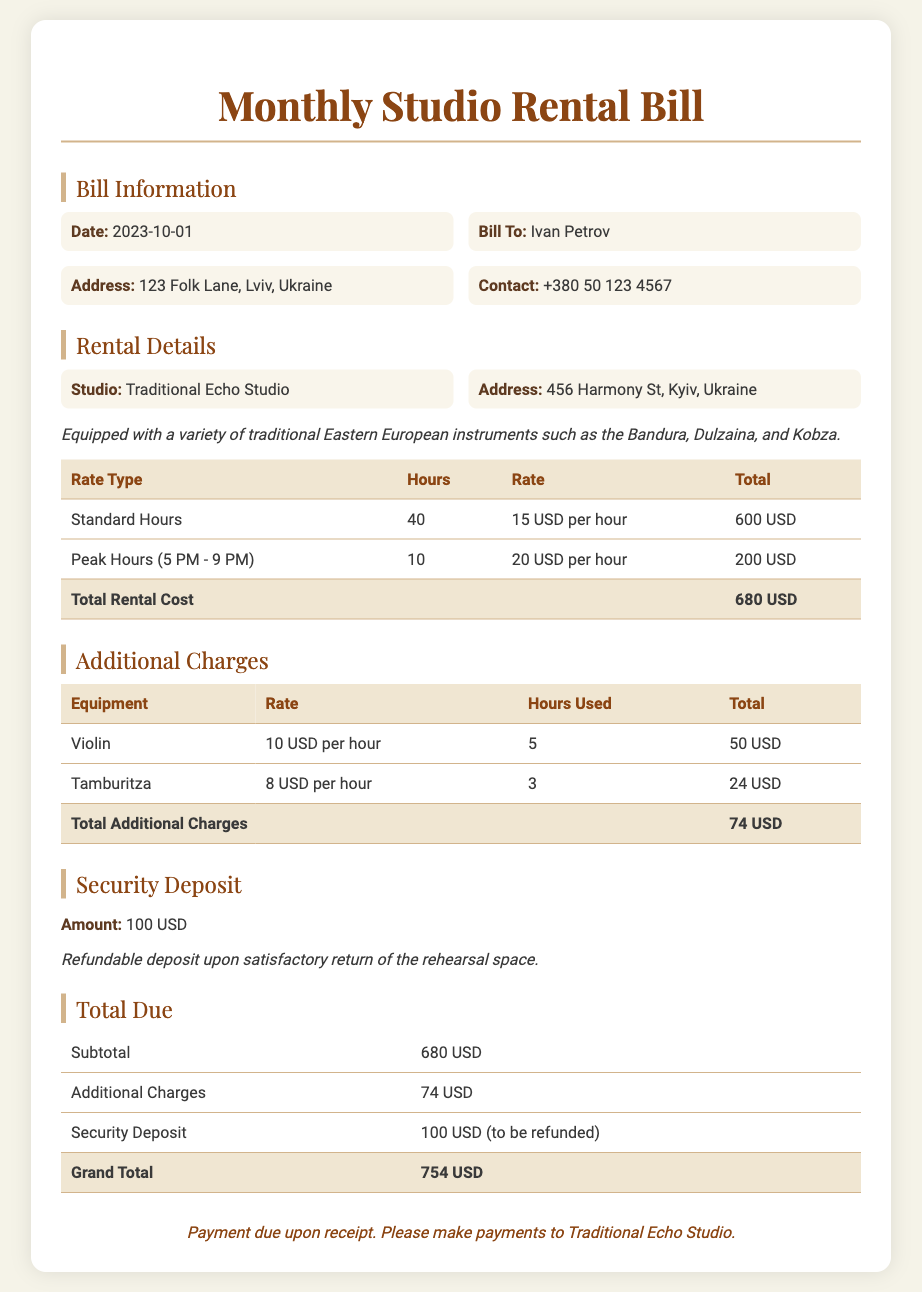What is the date of the bill? The date of the bill is explicitly stated in the document.
Answer: 2023-10-01 Who is the bill addressed to? The bill includes the name of the recipient in the bill information section.
Answer: Ivan Petrov What is the total rental cost? The total rental cost is calculated and presented in the rental details table.
Answer: 680 USD How many hours were used for peak hours? The peak hours usage is mentioned in the rental details table.
Answer: 10 What instruments are available in the studio? The document lists some specific traditional instruments present in the studio.
Answer: Bandura, Dulzaina, and Kobza What is the refundable security deposit amount? The amount for the security deposit is specified under the security deposit section.
Answer: 100 USD What is the total amount due? The total due is summarized in the total due section of the document.
Answer: 754 USD What is the rate for the Violin per hour? The rate for using the violin is found in the additional charges table.
Answer: 10 USD per hour What should payments be made to? The footer of the document specifies where payments should be directed.
Answer: Traditional Echo Studio 